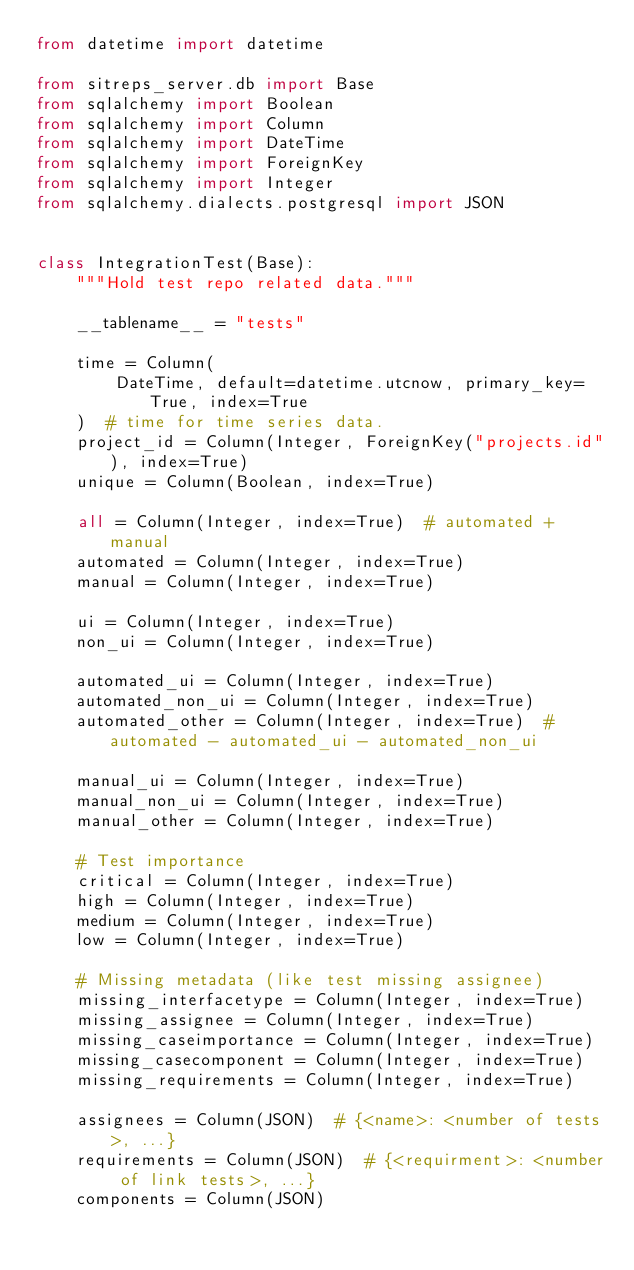<code> <loc_0><loc_0><loc_500><loc_500><_Python_>from datetime import datetime

from sitreps_server.db import Base
from sqlalchemy import Boolean
from sqlalchemy import Column
from sqlalchemy import DateTime
from sqlalchemy import ForeignKey
from sqlalchemy import Integer
from sqlalchemy.dialects.postgresql import JSON


class IntegrationTest(Base):
    """Hold test repo related data."""

    __tablename__ = "tests"

    time = Column(
        DateTime, default=datetime.utcnow, primary_key=True, index=True
    )  # time for time series data.
    project_id = Column(Integer, ForeignKey("projects.id"), index=True)
    unique = Column(Boolean, index=True)

    all = Column(Integer, index=True)  # automated + manual
    automated = Column(Integer, index=True)
    manual = Column(Integer, index=True)

    ui = Column(Integer, index=True)
    non_ui = Column(Integer, index=True)

    automated_ui = Column(Integer, index=True)
    automated_non_ui = Column(Integer, index=True)
    automated_other = Column(Integer, index=True)  # automated - automated_ui - automated_non_ui

    manual_ui = Column(Integer, index=True)
    manual_non_ui = Column(Integer, index=True)
    manual_other = Column(Integer, index=True)

    # Test importance
    critical = Column(Integer, index=True)
    high = Column(Integer, index=True)
    medium = Column(Integer, index=True)
    low = Column(Integer, index=True)

    # Missing metadata (like test missing assignee)
    missing_interfacetype = Column(Integer, index=True)
    missing_assignee = Column(Integer, index=True)
    missing_caseimportance = Column(Integer, index=True)
    missing_casecomponent = Column(Integer, index=True)
    missing_requirements = Column(Integer, index=True)

    assignees = Column(JSON)  # {<name>: <number of tests>, ...}
    requirements = Column(JSON)  # {<requirment>: <number of link tests>, ...}
    components = Column(JSON)
</code> 